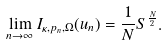Convert formula to latex. <formula><loc_0><loc_0><loc_500><loc_500>\lim _ { n \to \infty } I _ { \kappa , p _ { n } , \Omega } ( u _ { n } ) = \frac { 1 } { N } S ^ { \frac { N } { 2 } } .</formula> 